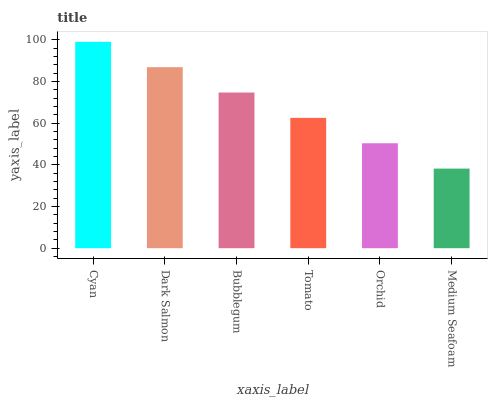Is Medium Seafoam the minimum?
Answer yes or no. Yes. Is Cyan the maximum?
Answer yes or no. Yes. Is Dark Salmon the minimum?
Answer yes or no. No. Is Dark Salmon the maximum?
Answer yes or no. No. Is Cyan greater than Dark Salmon?
Answer yes or no. Yes. Is Dark Salmon less than Cyan?
Answer yes or no. Yes. Is Dark Salmon greater than Cyan?
Answer yes or no. No. Is Cyan less than Dark Salmon?
Answer yes or no. No. Is Bubblegum the high median?
Answer yes or no. Yes. Is Tomato the low median?
Answer yes or no. Yes. Is Cyan the high median?
Answer yes or no. No. Is Dark Salmon the low median?
Answer yes or no. No. 